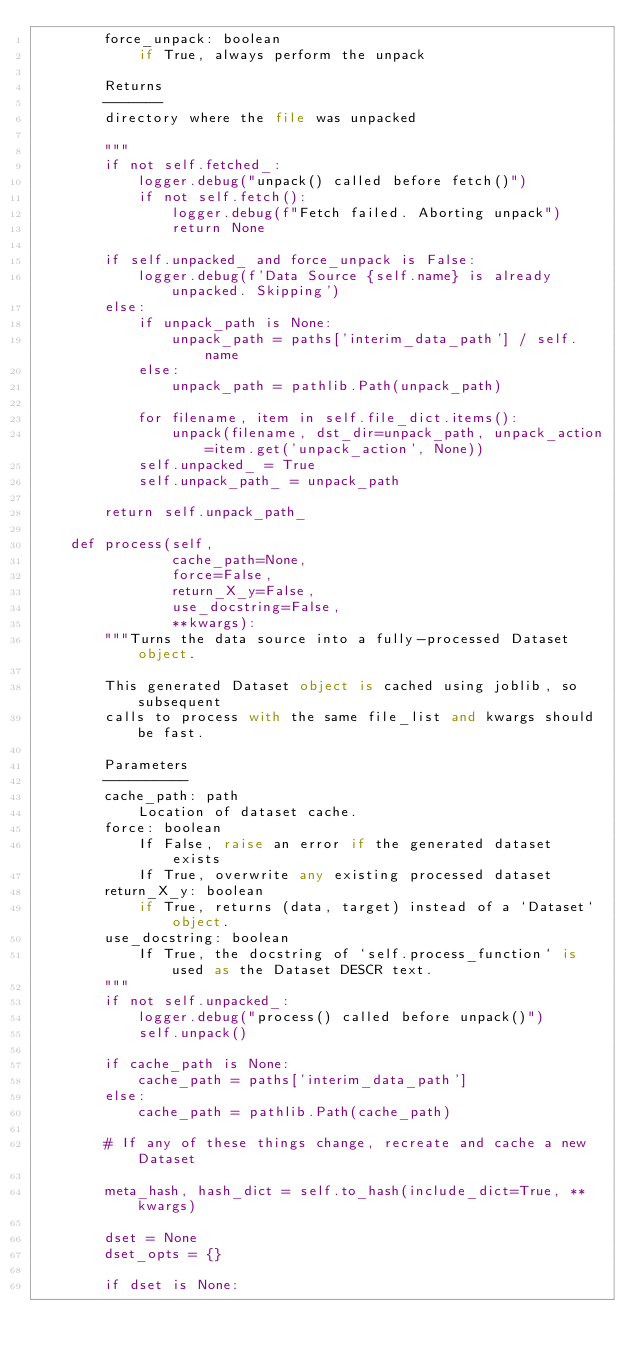<code> <loc_0><loc_0><loc_500><loc_500><_Python_>        force_unpack: boolean
            if True, always perform the unpack

        Returns
        -------
        directory where the file was unpacked

        """
        if not self.fetched_:
            logger.debug("unpack() called before fetch()")
            if not self.fetch():
                logger.debug(f"Fetch failed. Aborting unpack")
                return None

        if self.unpacked_ and force_unpack is False:
            logger.debug(f'Data Source {self.name} is already unpacked. Skipping')
        else:
            if unpack_path is None:
                unpack_path = paths['interim_data_path'] / self.name
            else:
                unpack_path = pathlib.Path(unpack_path)

            for filename, item in self.file_dict.items():
                unpack(filename, dst_dir=unpack_path, unpack_action=item.get('unpack_action', None))
            self.unpacked_ = True
            self.unpack_path_ = unpack_path

        return self.unpack_path_

    def process(self,
                cache_path=None,
                force=False,
                return_X_y=False,
                use_docstring=False,
                **kwargs):
        """Turns the data source into a fully-processed Dataset object.

        This generated Dataset object is cached using joblib, so subsequent
        calls to process with the same file_list and kwargs should be fast.

        Parameters
        ----------
        cache_path: path
            Location of dataset cache.
        force: boolean
            If False, raise an error if the generated dataset exists
            If True, overwrite any existing processed dataset
        return_X_y: boolean
            if True, returns (data, target) instead of a `Dataset` object.
        use_docstring: boolean
            If True, the docstring of `self.process_function` is used as the Dataset DESCR text.
        """
        if not self.unpacked_:
            logger.debug("process() called before unpack()")
            self.unpack()

        if cache_path is None:
            cache_path = paths['interim_data_path']
        else:
            cache_path = pathlib.Path(cache_path)

        # If any of these things change, recreate and cache a new Dataset

        meta_hash, hash_dict = self.to_hash(include_dict=True, **kwargs)

        dset = None
        dset_opts = {}

        if dset is None:</code> 